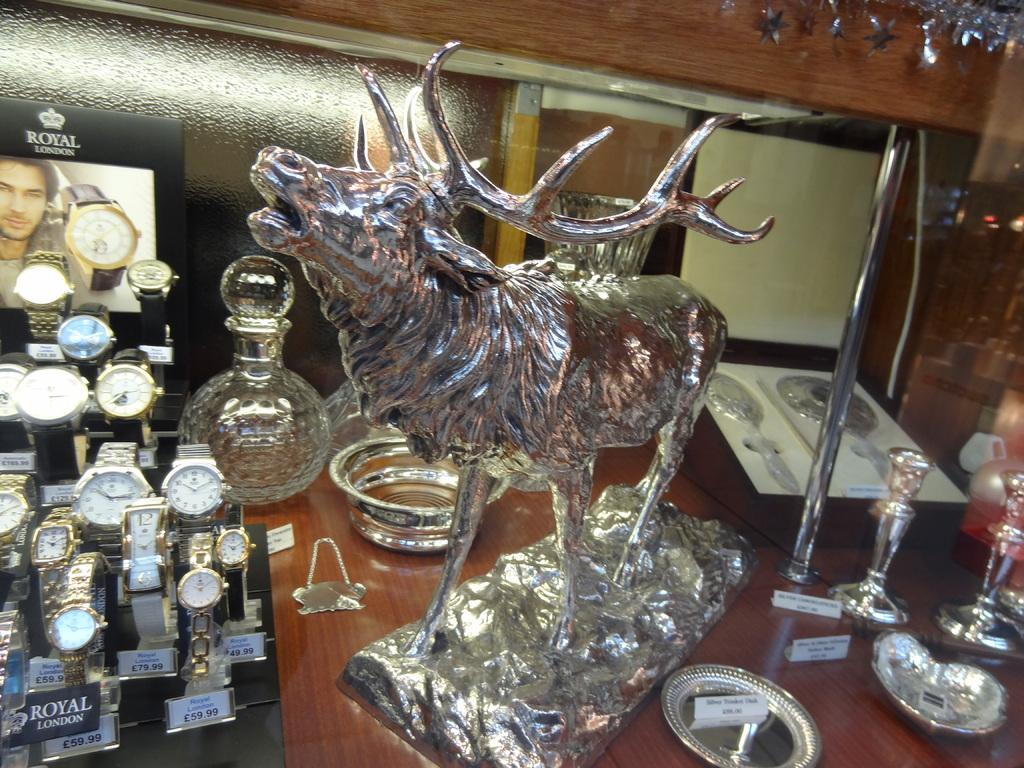What type of objects can be seen in the image? There are many wrist watches in the image. Where are these objects placed? The objects are on a wooden surface in the image. Can you describe any other items in the image? There is a metal sculpture of an animal in the image. What type of fire can be seen in the image? There is no fire present in the image. How many points does the animal sculpture have in the image? The metal sculpture of an animal does not have points; it is a solid sculpture. 